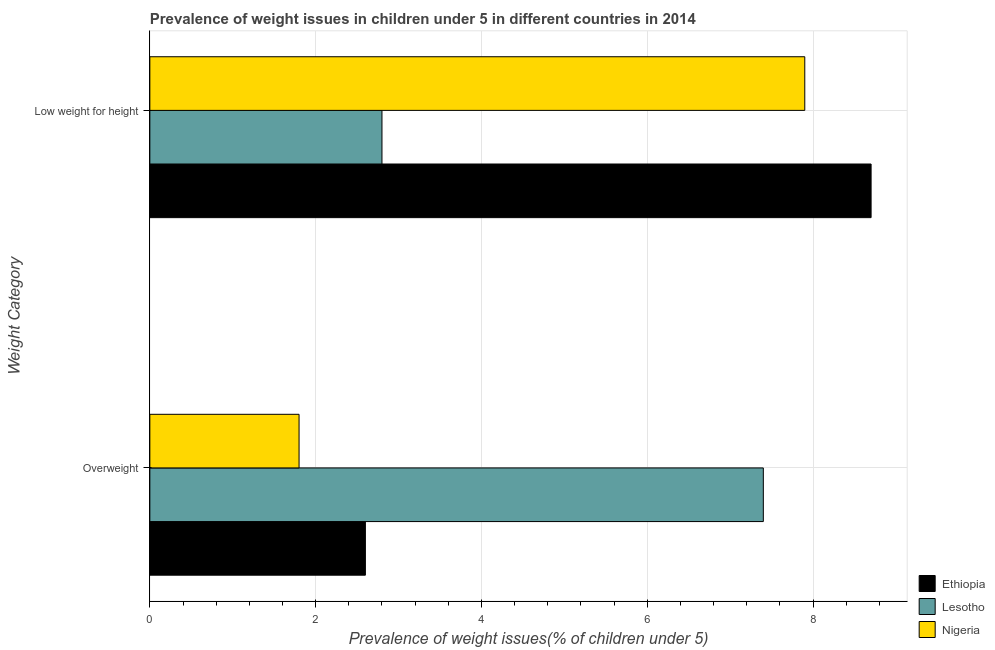How many groups of bars are there?
Your answer should be compact. 2. Are the number of bars per tick equal to the number of legend labels?
Your response must be concise. Yes. Are the number of bars on each tick of the Y-axis equal?
Your response must be concise. Yes. How many bars are there on the 1st tick from the top?
Keep it short and to the point. 3. What is the label of the 1st group of bars from the top?
Provide a short and direct response. Low weight for height. What is the percentage of overweight children in Ethiopia?
Your response must be concise. 2.6. Across all countries, what is the maximum percentage of overweight children?
Provide a succinct answer. 7.4. Across all countries, what is the minimum percentage of overweight children?
Offer a terse response. 1.8. In which country was the percentage of underweight children maximum?
Offer a terse response. Ethiopia. In which country was the percentage of overweight children minimum?
Make the answer very short. Nigeria. What is the total percentage of overweight children in the graph?
Ensure brevity in your answer.  11.8. What is the difference between the percentage of underweight children in Nigeria and that in Ethiopia?
Your answer should be very brief. -0.8. What is the difference between the percentage of overweight children in Nigeria and the percentage of underweight children in Ethiopia?
Your answer should be compact. -6.9. What is the average percentage of overweight children per country?
Keep it short and to the point. 3.93. What is the difference between the percentage of underweight children and percentage of overweight children in Ethiopia?
Make the answer very short. 6.1. In how many countries, is the percentage of overweight children greater than 2 %?
Offer a very short reply. 2. What is the ratio of the percentage of underweight children in Nigeria to that in Ethiopia?
Offer a terse response. 0.91. Is the percentage of overweight children in Nigeria less than that in Ethiopia?
Give a very brief answer. Yes. What does the 3rd bar from the top in Overweight represents?
Ensure brevity in your answer.  Ethiopia. What does the 3rd bar from the bottom in Low weight for height represents?
Keep it short and to the point. Nigeria. How many bars are there?
Provide a short and direct response. 6. How many countries are there in the graph?
Your answer should be compact. 3. Does the graph contain any zero values?
Provide a succinct answer. No. Does the graph contain grids?
Give a very brief answer. Yes. How many legend labels are there?
Ensure brevity in your answer.  3. What is the title of the graph?
Ensure brevity in your answer.  Prevalence of weight issues in children under 5 in different countries in 2014. What is the label or title of the X-axis?
Your response must be concise. Prevalence of weight issues(% of children under 5). What is the label or title of the Y-axis?
Give a very brief answer. Weight Category. What is the Prevalence of weight issues(% of children under 5) in Ethiopia in Overweight?
Offer a terse response. 2.6. What is the Prevalence of weight issues(% of children under 5) in Lesotho in Overweight?
Provide a short and direct response. 7.4. What is the Prevalence of weight issues(% of children under 5) in Nigeria in Overweight?
Your response must be concise. 1.8. What is the Prevalence of weight issues(% of children under 5) of Ethiopia in Low weight for height?
Provide a succinct answer. 8.7. What is the Prevalence of weight issues(% of children under 5) of Lesotho in Low weight for height?
Make the answer very short. 2.8. What is the Prevalence of weight issues(% of children under 5) of Nigeria in Low weight for height?
Your answer should be very brief. 7.9. Across all Weight Category, what is the maximum Prevalence of weight issues(% of children under 5) of Ethiopia?
Offer a terse response. 8.7. Across all Weight Category, what is the maximum Prevalence of weight issues(% of children under 5) in Lesotho?
Your answer should be compact. 7.4. Across all Weight Category, what is the maximum Prevalence of weight issues(% of children under 5) in Nigeria?
Your answer should be very brief. 7.9. Across all Weight Category, what is the minimum Prevalence of weight issues(% of children under 5) in Ethiopia?
Your response must be concise. 2.6. Across all Weight Category, what is the minimum Prevalence of weight issues(% of children under 5) in Lesotho?
Keep it short and to the point. 2.8. Across all Weight Category, what is the minimum Prevalence of weight issues(% of children under 5) in Nigeria?
Give a very brief answer. 1.8. What is the total Prevalence of weight issues(% of children under 5) of Nigeria in the graph?
Keep it short and to the point. 9.7. What is the difference between the Prevalence of weight issues(% of children under 5) of Ethiopia in Overweight and that in Low weight for height?
Your response must be concise. -6.1. What is the difference between the Prevalence of weight issues(% of children under 5) of Lesotho in Overweight and that in Low weight for height?
Give a very brief answer. 4.6. What is the difference between the Prevalence of weight issues(% of children under 5) in Ethiopia in Overweight and the Prevalence of weight issues(% of children under 5) in Lesotho in Low weight for height?
Offer a very short reply. -0.2. What is the difference between the Prevalence of weight issues(% of children under 5) in Ethiopia in Overweight and the Prevalence of weight issues(% of children under 5) in Nigeria in Low weight for height?
Give a very brief answer. -5.3. What is the average Prevalence of weight issues(% of children under 5) in Ethiopia per Weight Category?
Provide a short and direct response. 5.65. What is the average Prevalence of weight issues(% of children under 5) in Lesotho per Weight Category?
Your answer should be very brief. 5.1. What is the average Prevalence of weight issues(% of children under 5) of Nigeria per Weight Category?
Offer a terse response. 4.85. What is the difference between the Prevalence of weight issues(% of children under 5) of Lesotho and Prevalence of weight issues(% of children under 5) of Nigeria in Overweight?
Provide a short and direct response. 5.6. What is the ratio of the Prevalence of weight issues(% of children under 5) of Ethiopia in Overweight to that in Low weight for height?
Provide a short and direct response. 0.3. What is the ratio of the Prevalence of weight issues(% of children under 5) in Lesotho in Overweight to that in Low weight for height?
Give a very brief answer. 2.64. What is the ratio of the Prevalence of weight issues(% of children under 5) in Nigeria in Overweight to that in Low weight for height?
Provide a short and direct response. 0.23. What is the difference between the highest and the second highest Prevalence of weight issues(% of children under 5) of Ethiopia?
Keep it short and to the point. 6.1. What is the difference between the highest and the lowest Prevalence of weight issues(% of children under 5) in Ethiopia?
Keep it short and to the point. 6.1. What is the difference between the highest and the lowest Prevalence of weight issues(% of children under 5) of Lesotho?
Your response must be concise. 4.6. 